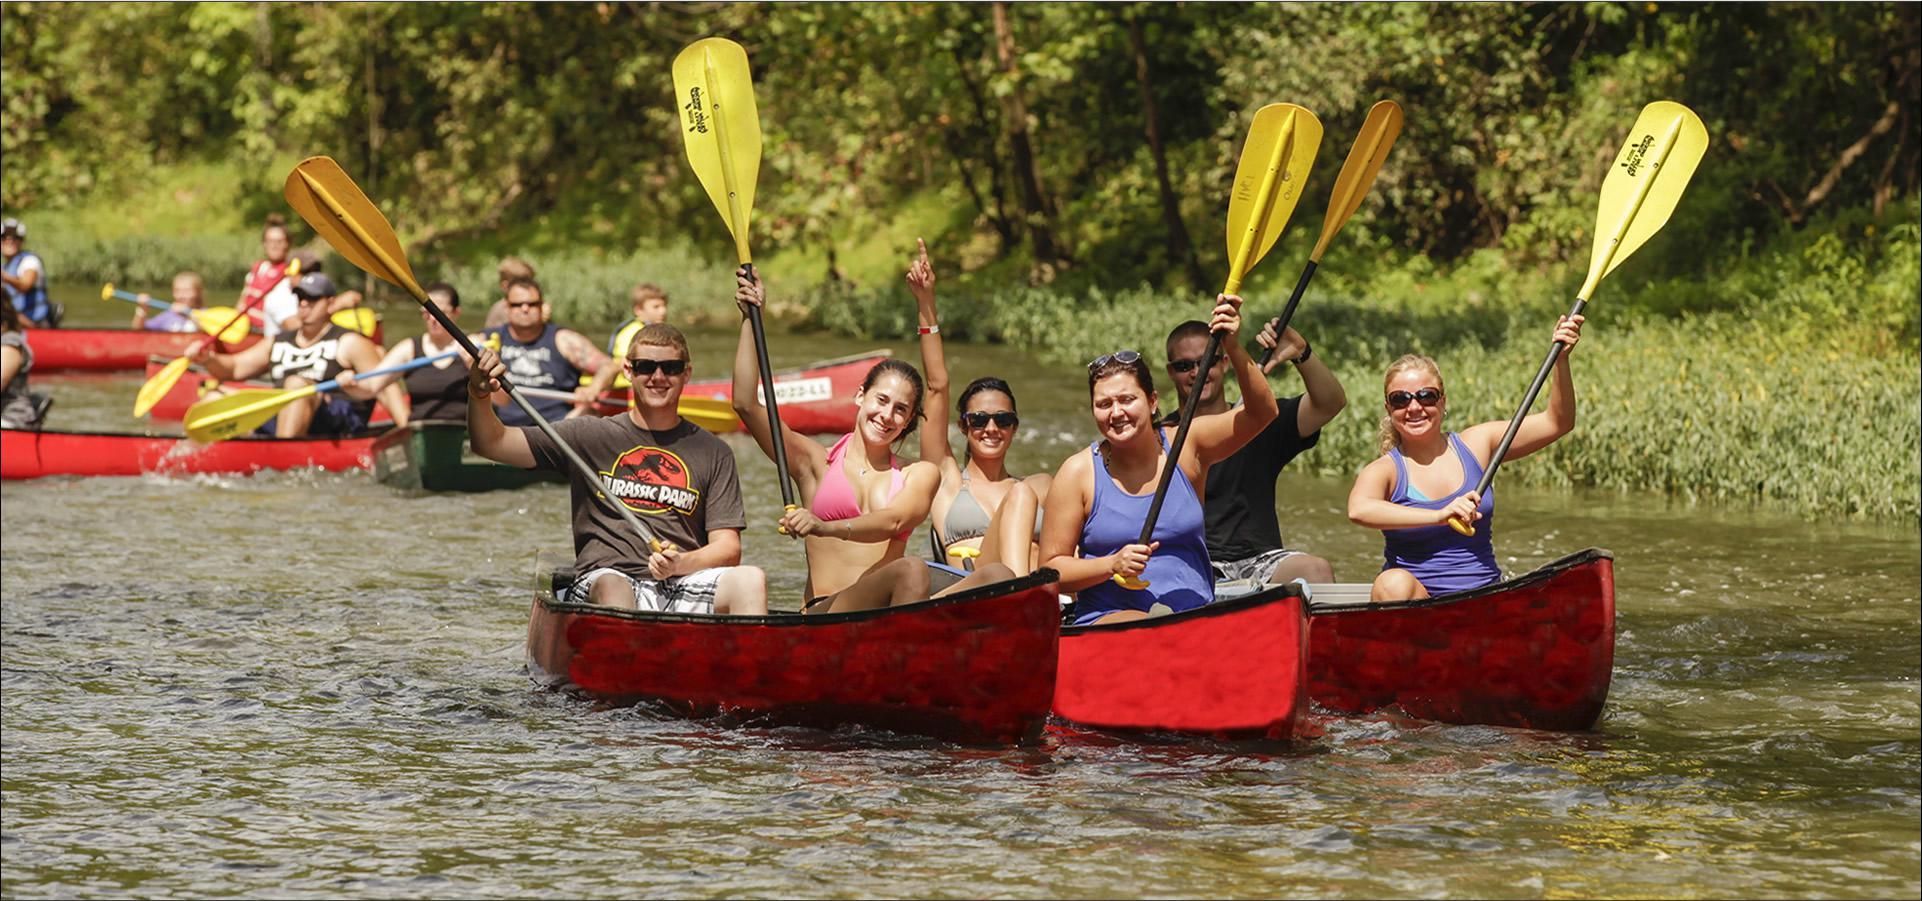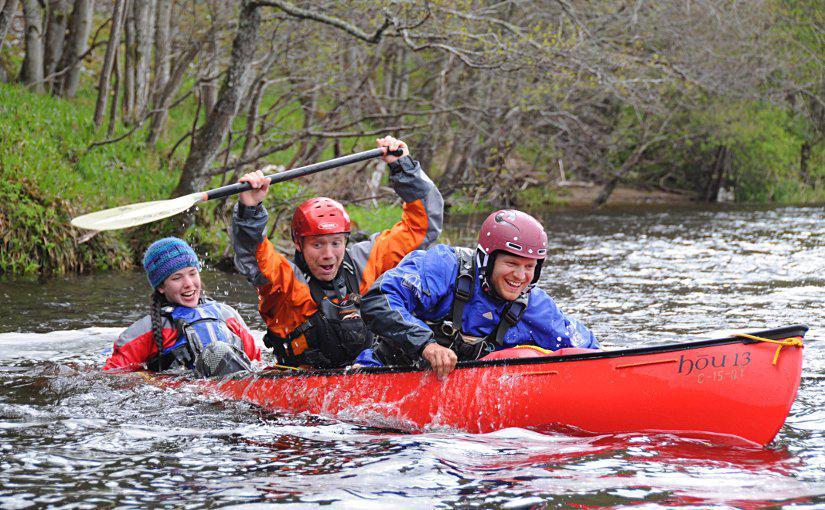The first image is the image on the left, the second image is the image on the right. Analyze the images presented: Is the assertion "There's at least one yellow paddle shown." valid? Answer yes or no. Yes. The first image is the image on the left, the second image is the image on the right. For the images shown, is this caption "there are exactly two people in the image on the right" true? Answer yes or no. No. 